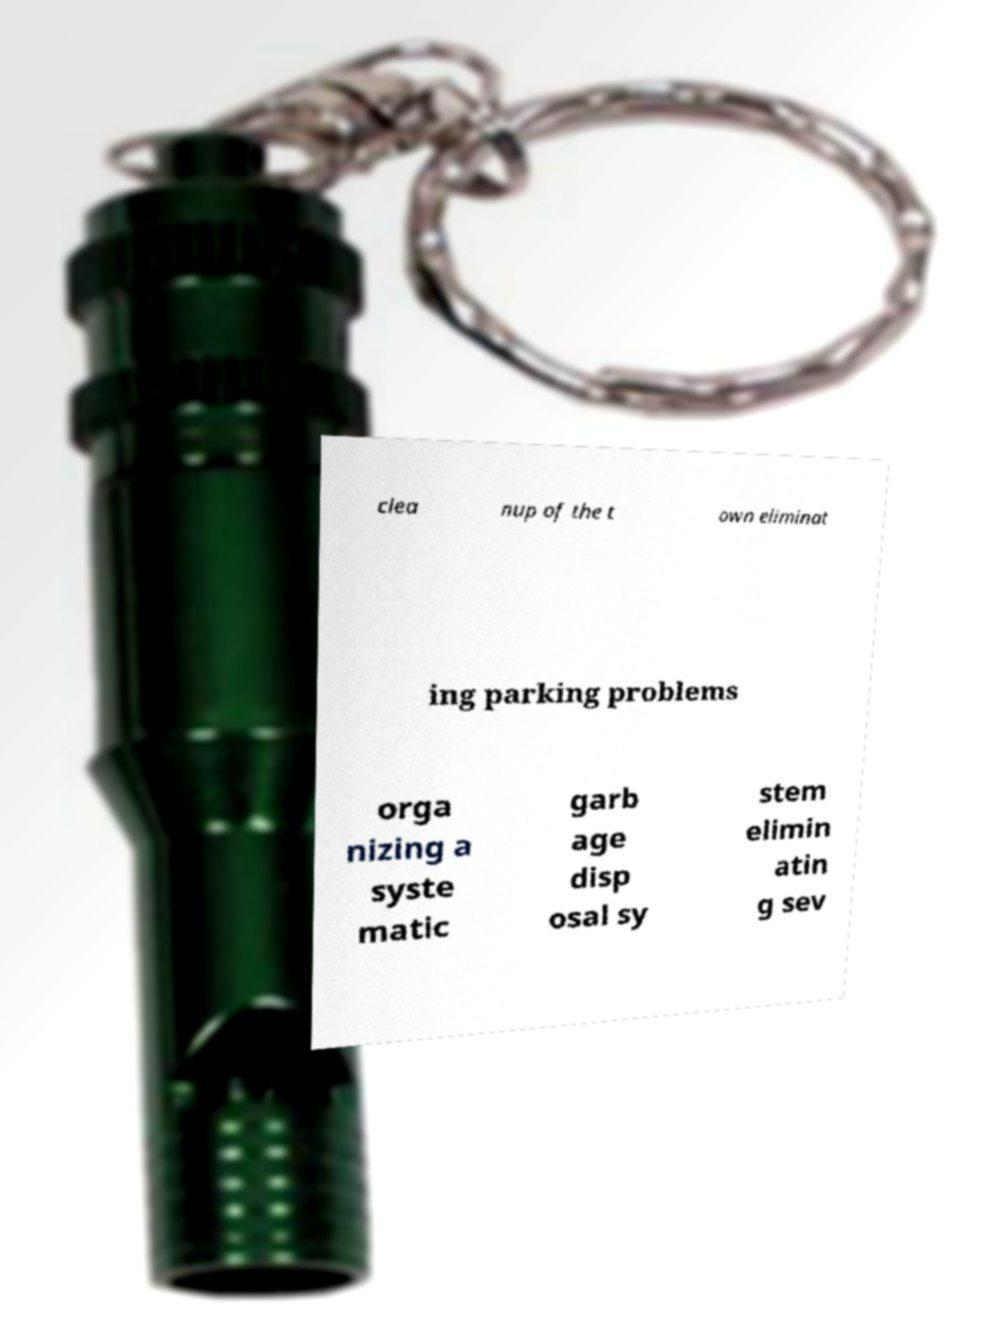For documentation purposes, I need the text within this image transcribed. Could you provide that? clea nup of the t own eliminat ing parking problems orga nizing a syste matic garb age disp osal sy stem elimin atin g sev 